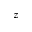<formula> <loc_0><loc_0><loc_500><loc_500>z</formula> 